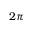<formula> <loc_0><loc_0><loc_500><loc_500>2 \pi</formula> 